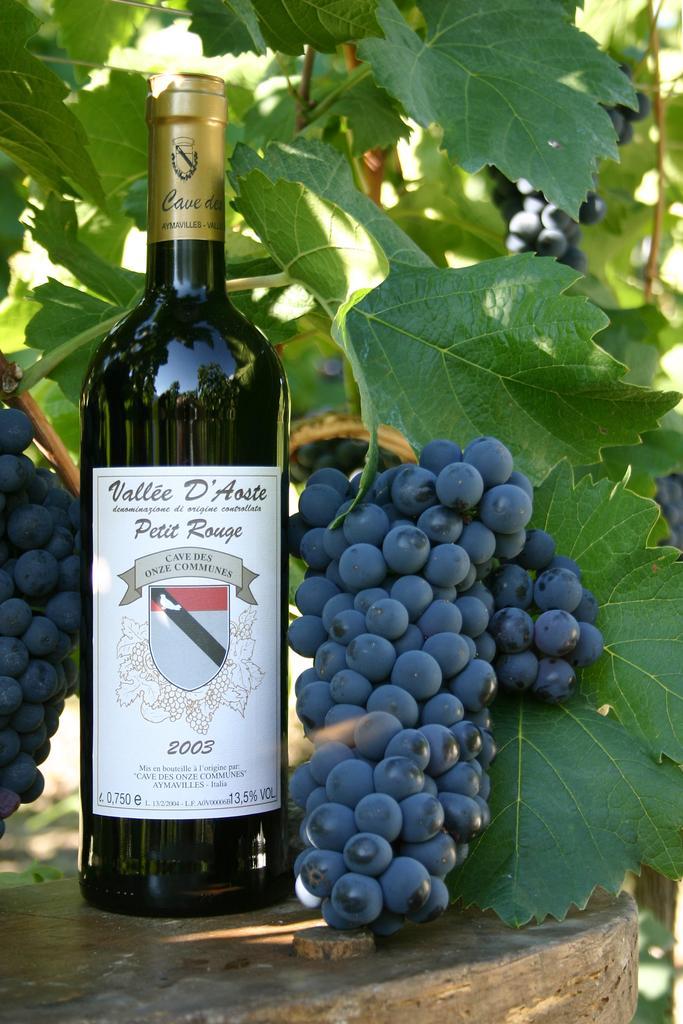How would you summarize this image in a sentence or two? In this image in front there are grapes. Beside the grapes there is a wine bottle. Behind the wine bottle there are leaves. 